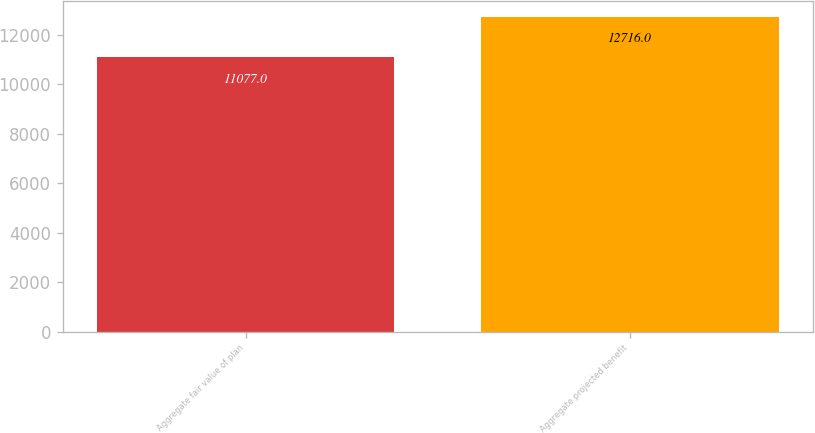Convert chart to OTSL. <chart><loc_0><loc_0><loc_500><loc_500><bar_chart><fcel>Aggregate fair value of plan<fcel>Aggregate projected benefit<nl><fcel>11077<fcel>12716<nl></chart> 